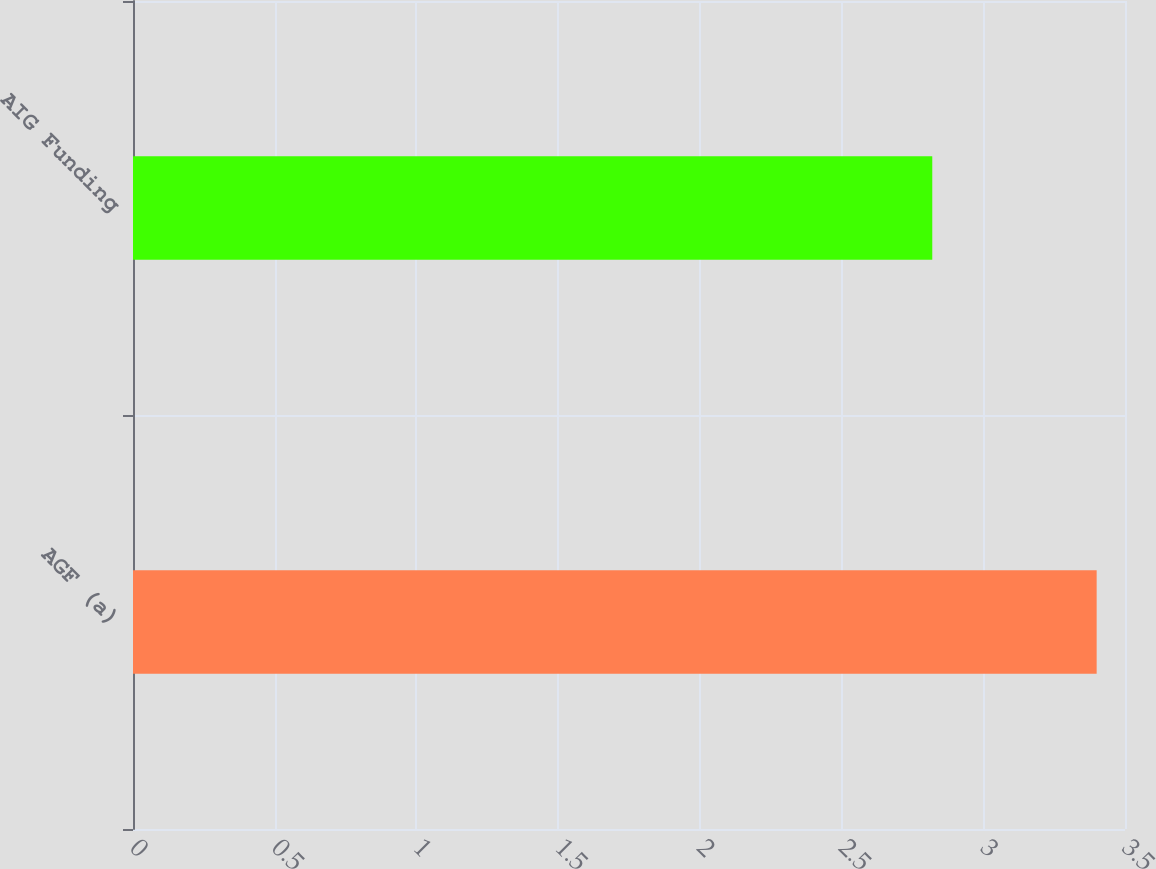Convert chart to OTSL. <chart><loc_0><loc_0><loc_500><loc_500><bar_chart><fcel>AGF (a)<fcel>AIG Funding<nl><fcel>3.4<fcel>2.82<nl></chart> 